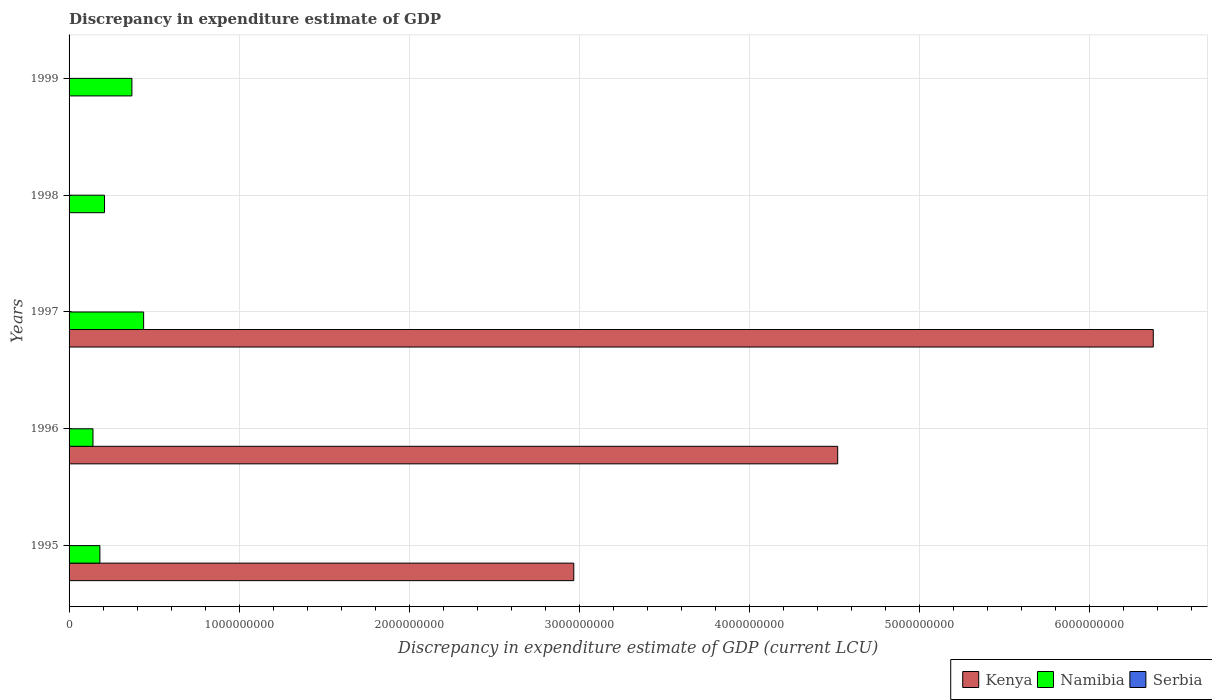How many different coloured bars are there?
Provide a short and direct response. 3. Are the number of bars per tick equal to the number of legend labels?
Keep it short and to the point. No. How many bars are there on the 1st tick from the top?
Make the answer very short. 1. How many bars are there on the 2nd tick from the bottom?
Provide a succinct answer. 3. What is the label of the 2nd group of bars from the top?
Ensure brevity in your answer.  1998. In how many cases, is the number of bars for a given year not equal to the number of legend labels?
Your response must be concise. 4. What is the discrepancy in expenditure estimate of GDP in Serbia in 1998?
Provide a succinct answer. 8e-6. Across all years, what is the maximum discrepancy in expenditure estimate of GDP in Serbia?
Ensure brevity in your answer.  1.00e+05. In which year was the discrepancy in expenditure estimate of GDP in Serbia maximum?
Offer a terse response. 1996. What is the total discrepancy in expenditure estimate of GDP in Kenya in the graph?
Offer a terse response. 1.39e+1. What is the difference between the discrepancy in expenditure estimate of GDP in Namibia in 1996 and that in 1997?
Offer a very short reply. -2.98e+08. What is the difference between the discrepancy in expenditure estimate of GDP in Serbia in 1996 and the discrepancy in expenditure estimate of GDP in Namibia in 1995?
Your response must be concise. -1.81e+08. What is the average discrepancy in expenditure estimate of GDP in Serbia per year?
Offer a terse response. 2.00e+04. In the year 1997, what is the difference between the discrepancy in expenditure estimate of GDP in Kenya and discrepancy in expenditure estimate of GDP in Namibia?
Offer a terse response. 5.94e+09. In how many years, is the discrepancy in expenditure estimate of GDP in Serbia greater than 2200000000 LCU?
Keep it short and to the point. 0. What is the ratio of the discrepancy in expenditure estimate of GDP in Kenya in 1995 to that in 1997?
Your answer should be compact. 0.47. What is the difference between the highest and the second highest discrepancy in expenditure estimate of GDP in Namibia?
Give a very brief answer. 6.90e+07. What is the difference between the highest and the lowest discrepancy in expenditure estimate of GDP in Namibia?
Make the answer very short. 2.98e+08. In how many years, is the discrepancy in expenditure estimate of GDP in Namibia greater than the average discrepancy in expenditure estimate of GDP in Namibia taken over all years?
Your answer should be compact. 2. Is the sum of the discrepancy in expenditure estimate of GDP in Namibia in 1997 and 1998 greater than the maximum discrepancy in expenditure estimate of GDP in Serbia across all years?
Make the answer very short. Yes. Is it the case that in every year, the sum of the discrepancy in expenditure estimate of GDP in Serbia and discrepancy in expenditure estimate of GDP in Kenya is greater than the discrepancy in expenditure estimate of GDP in Namibia?
Offer a terse response. No. How many bars are there?
Keep it short and to the point. 10. Are all the bars in the graph horizontal?
Give a very brief answer. Yes. What is the difference between two consecutive major ticks on the X-axis?
Offer a terse response. 1.00e+09. Does the graph contain grids?
Your answer should be very brief. Yes. Where does the legend appear in the graph?
Your response must be concise. Bottom right. What is the title of the graph?
Provide a short and direct response. Discrepancy in expenditure estimate of GDP. Does "Philippines" appear as one of the legend labels in the graph?
Your answer should be very brief. No. What is the label or title of the X-axis?
Provide a short and direct response. Discrepancy in expenditure estimate of GDP (current LCU). What is the label or title of the Y-axis?
Your response must be concise. Years. What is the Discrepancy in expenditure estimate of GDP (current LCU) of Kenya in 1995?
Provide a short and direct response. 2.97e+09. What is the Discrepancy in expenditure estimate of GDP (current LCU) of Namibia in 1995?
Your answer should be very brief. 1.81e+08. What is the Discrepancy in expenditure estimate of GDP (current LCU) in Serbia in 1995?
Your answer should be compact. 0. What is the Discrepancy in expenditure estimate of GDP (current LCU) in Kenya in 1996?
Keep it short and to the point. 4.52e+09. What is the Discrepancy in expenditure estimate of GDP (current LCU) of Namibia in 1996?
Give a very brief answer. 1.41e+08. What is the Discrepancy in expenditure estimate of GDP (current LCU) in Serbia in 1996?
Ensure brevity in your answer.  1.00e+05. What is the Discrepancy in expenditure estimate of GDP (current LCU) of Kenya in 1997?
Provide a short and direct response. 6.38e+09. What is the Discrepancy in expenditure estimate of GDP (current LCU) in Namibia in 1997?
Offer a very short reply. 4.38e+08. What is the Discrepancy in expenditure estimate of GDP (current LCU) in Kenya in 1998?
Ensure brevity in your answer.  0. What is the Discrepancy in expenditure estimate of GDP (current LCU) in Namibia in 1998?
Ensure brevity in your answer.  2.09e+08. What is the Discrepancy in expenditure estimate of GDP (current LCU) of Serbia in 1998?
Ensure brevity in your answer.  8e-6. What is the Discrepancy in expenditure estimate of GDP (current LCU) of Namibia in 1999?
Offer a terse response. 3.69e+08. Across all years, what is the maximum Discrepancy in expenditure estimate of GDP (current LCU) of Kenya?
Make the answer very short. 6.38e+09. Across all years, what is the maximum Discrepancy in expenditure estimate of GDP (current LCU) of Namibia?
Make the answer very short. 4.38e+08. Across all years, what is the maximum Discrepancy in expenditure estimate of GDP (current LCU) in Serbia?
Your answer should be compact. 1.00e+05. Across all years, what is the minimum Discrepancy in expenditure estimate of GDP (current LCU) of Namibia?
Make the answer very short. 1.41e+08. Across all years, what is the minimum Discrepancy in expenditure estimate of GDP (current LCU) of Serbia?
Your response must be concise. 0. What is the total Discrepancy in expenditure estimate of GDP (current LCU) in Kenya in the graph?
Keep it short and to the point. 1.39e+1. What is the total Discrepancy in expenditure estimate of GDP (current LCU) of Namibia in the graph?
Offer a very short reply. 1.34e+09. What is the total Discrepancy in expenditure estimate of GDP (current LCU) of Serbia in the graph?
Ensure brevity in your answer.  1.00e+05. What is the difference between the Discrepancy in expenditure estimate of GDP (current LCU) in Kenya in 1995 and that in 1996?
Provide a short and direct response. -1.55e+09. What is the difference between the Discrepancy in expenditure estimate of GDP (current LCU) of Namibia in 1995 and that in 1996?
Ensure brevity in your answer.  4.07e+07. What is the difference between the Discrepancy in expenditure estimate of GDP (current LCU) of Kenya in 1995 and that in 1997?
Your answer should be compact. -3.41e+09. What is the difference between the Discrepancy in expenditure estimate of GDP (current LCU) of Namibia in 1995 and that in 1997?
Provide a succinct answer. -2.57e+08. What is the difference between the Discrepancy in expenditure estimate of GDP (current LCU) of Namibia in 1995 and that in 1998?
Your response must be concise. -2.73e+07. What is the difference between the Discrepancy in expenditure estimate of GDP (current LCU) in Namibia in 1995 and that in 1999?
Give a very brief answer. -1.88e+08. What is the difference between the Discrepancy in expenditure estimate of GDP (current LCU) in Kenya in 1996 and that in 1997?
Your answer should be very brief. -1.86e+09. What is the difference between the Discrepancy in expenditure estimate of GDP (current LCU) in Namibia in 1996 and that in 1997?
Your answer should be very brief. -2.98e+08. What is the difference between the Discrepancy in expenditure estimate of GDP (current LCU) in Namibia in 1996 and that in 1998?
Keep it short and to the point. -6.79e+07. What is the difference between the Discrepancy in expenditure estimate of GDP (current LCU) in Namibia in 1996 and that in 1999?
Make the answer very short. -2.29e+08. What is the difference between the Discrepancy in expenditure estimate of GDP (current LCU) in Namibia in 1997 and that in 1998?
Keep it short and to the point. 2.30e+08. What is the difference between the Discrepancy in expenditure estimate of GDP (current LCU) in Namibia in 1997 and that in 1999?
Provide a short and direct response. 6.90e+07. What is the difference between the Discrepancy in expenditure estimate of GDP (current LCU) in Namibia in 1998 and that in 1999?
Ensure brevity in your answer.  -1.61e+08. What is the difference between the Discrepancy in expenditure estimate of GDP (current LCU) of Kenya in 1995 and the Discrepancy in expenditure estimate of GDP (current LCU) of Namibia in 1996?
Offer a terse response. 2.83e+09. What is the difference between the Discrepancy in expenditure estimate of GDP (current LCU) of Kenya in 1995 and the Discrepancy in expenditure estimate of GDP (current LCU) of Serbia in 1996?
Your answer should be very brief. 2.97e+09. What is the difference between the Discrepancy in expenditure estimate of GDP (current LCU) of Namibia in 1995 and the Discrepancy in expenditure estimate of GDP (current LCU) of Serbia in 1996?
Offer a terse response. 1.81e+08. What is the difference between the Discrepancy in expenditure estimate of GDP (current LCU) in Kenya in 1995 and the Discrepancy in expenditure estimate of GDP (current LCU) in Namibia in 1997?
Provide a succinct answer. 2.53e+09. What is the difference between the Discrepancy in expenditure estimate of GDP (current LCU) in Kenya in 1995 and the Discrepancy in expenditure estimate of GDP (current LCU) in Namibia in 1998?
Your answer should be compact. 2.76e+09. What is the difference between the Discrepancy in expenditure estimate of GDP (current LCU) of Kenya in 1995 and the Discrepancy in expenditure estimate of GDP (current LCU) of Serbia in 1998?
Offer a very short reply. 2.97e+09. What is the difference between the Discrepancy in expenditure estimate of GDP (current LCU) of Namibia in 1995 and the Discrepancy in expenditure estimate of GDP (current LCU) of Serbia in 1998?
Offer a very short reply. 1.81e+08. What is the difference between the Discrepancy in expenditure estimate of GDP (current LCU) in Kenya in 1995 and the Discrepancy in expenditure estimate of GDP (current LCU) in Namibia in 1999?
Offer a terse response. 2.60e+09. What is the difference between the Discrepancy in expenditure estimate of GDP (current LCU) of Kenya in 1996 and the Discrepancy in expenditure estimate of GDP (current LCU) of Namibia in 1997?
Provide a succinct answer. 4.08e+09. What is the difference between the Discrepancy in expenditure estimate of GDP (current LCU) of Kenya in 1996 and the Discrepancy in expenditure estimate of GDP (current LCU) of Namibia in 1998?
Your answer should be very brief. 4.31e+09. What is the difference between the Discrepancy in expenditure estimate of GDP (current LCU) of Kenya in 1996 and the Discrepancy in expenditure estimate of GDP (current LCU) of Serbia in 1998?
Offer a very short reply. 4.52e+09. What is the difference between the Discrepancy in expenditure estimate of GDP (current LCU) in Namibia in 1996 and the Discrepancy in expenditure estimate of GDP (current LCU) in Serbia in 1998?
Offer a very short reply. 1.41e+08. What is the difference between the Discrepancy in expenditure estimate of GDP (current LCU) in Kenya in 1996 and the Discrepancy in expenditure estimate of GDP (current LCU) in Namibia in 1999?
Keep it short and to the point. 4.15e+09. What is the difference between the Discrepancy in expenditure estimate of GDP (current LCU) in Kenya in 1997 and the Discrepancy in expenditure estimate of GDP (current LCU) in Namibia in 1998?
Keep it short and to the point. 6.17e+09. What is the difference between the Discrepancy in expenditure estimate of GDP (current LCU) in Kenya in 1997 and the Discrepancy in expenditure estimate of GDP (current LCU) in Serbia in 1998?
Give a very brief answer. 6.38e+09. What is the difference between the Discrepancy in expenditure estimate of GDP (current LCU) in Namibia in 1997 and the Discrepancy in expenditure estimate of GDP (current LCU) in Serbia in 1998?
Give a very brief answer. 4.38e+08. What is the difference between the Discrepancy in expenditure estimate of GDP (current LCU) of Kenya in 1997 and the Discrepancy in expenditure estimate of GDP (current LCU) of Namibia in 1999?
Offer a terse response. 6.01e+09. What is the average Discrepancy in expenditure estimate of GDP (current LCU) in Kenya per year?
Provide a succinct answer. 2.77e+09. What is the average Discrepancy in expenditure estimate of GDP (current LCU) of Namibia per year?
Offer a very short reply. 2.68e+08. In the year 1995, what is the difference between the Discrepancy in expenditure estimate of GDP (current LCU) of Kenya and Discrepancy in expenditure estimate of GDP (current LCU) of Namibia?
Offer a terse response. 2.79e+09. In the year 1996, what is the difference between the Discrepancy in expenditure estimate of GDP (current LCU) of Kenya and Discrepancy in expenditure estimate of GDP (current LCU) of Namibia?
Offer a terse response. 4.38e+09. In the year 1996, what is the difference between the Discrepancy in expenditure estimate of GDP (current LCU) in Kenya and Discrepancy in expenditure estimate of GDP (current LCU) in Serbia?
Keep it short and to the point. 4.52e+09. In the year 1996, what is the difference between the Discrepancy in expenditure estimate of GDP (current LCU) in Namibia and Discrepancy in expenditure estimate of GDP (current LCU) in Serbia?
Give a very brief answer. 1.40e+08. In the year 1997, what is the difference between the Discrepancy in expenditure estimate of GDP (current LCU) in Kenya and Discrepancy in expenditure estimate of GDP (current LCU) in Namibia?
Provide a short and direct response. 5.94e+09. In the year 1998, what is the difference between the Discrepancy in expenditure estimate of GDP (current LCU) in Namibia and Discrepancy in expenditure estimate of GDP (current LCU) in Serbia?
Your response must be concise. 2.09e+08. What is the ratio of the Discrepancy in expenditure estimate of GDP (current LCU) in Kenya in 1995 to that in 1996?
Make the answer very short. 0.66. What is the ratio of the Discrepancy in expenditure estimate of GDP (current LCU) of Namibia in 1995 to that in 1996?
Your response must be concise. 1.29. What is the ratio of the Discrepancy in expenditure estimate of GDP (current LCU) in Kenya in 1995 to that in 1997?
Ensure brevity in your answer.  0.47. What is the ratio of the Discrepancy in expenditure estimate of GDP (current LCU) of Namibia in 1995 to that in 1997?
Your answer should be very brief. 0.41. What is the ratio of the Discrepancy in expenditure estimate of GDP (current LCU) of Namibia in 1995 to that in 1998?
Make the answer very short. 0.87. What is the ratio of the Discrepancy in expenditure estimate of GDP (current LCU) in Namibia in 1995 to that in 1999?
Offer a very short reply. 0.49. What is the ratio of the Discrepancy in expenditure estimate of GDP (current LCU) of Kenya in 1996 to that in 1997?
Offer a terse response. 0.71. What is the ratio of the Discrepancy in expenditure estimate of GDP (current LCU) of Namibia in 1996 to that in 1997?
Keep it short and to the point. 0.32. What is the ratio of the Discrepancy in expenditure estimate of GDP (current LCU) in Namibia in 1996 to that in 1998?
Your response must be concise. 0.67. What is the ratio of the Discrepancy in expenditure estimate of GDP (current LCU) of Serbia in 1996 to that in 1998?
Give a very brief answer. 1.25e+1. What is the ratio of the Discrepancy in expenditure estimate of GDP (current LCU) in Namibia in 1996 to that in 1999?
Your answer should be compact. 0.38. What is the ratio of the Discrepancy in expenditure estimate of GDP (current LCU) of Namibia in 1997 to that in 1998?
Offer a terse response. 2.1. What is the ratio of the Discrepancy in expenditure estimate of GDP (current LCU) in Namibia in 1997 to that in 1999?
Provide a short and direct response. 1.19. What is the ratio of the Discrepancy in expenditure estimate of GDP (current LCU) in Namibia in 1998 to that in 1999?
Give a very brief answer. 0.56. What is the difference between the highest and the second highest Discrepancy in expenditure estimate of GDP (current LCU) of Kenya?
Offer a very short reply. 1.86e+09. What is the difference between the highest and the second highest Discrepancy in expenditure estimate of GDP (current LCU) of Namibia?
Make the answer very short. 6.90e+07. What is the difference between the highest and the lowest Discrepancy in expenditure estimate of GDP (current LCU) in Kenya?
Your answer should be very brief. 6.38e+09. What is the difference between the highest and the lowest Discrepancy in expenditure estimate of GDP (current LCU) in Namibia?
Offer a terse response. 2.98e+08. 